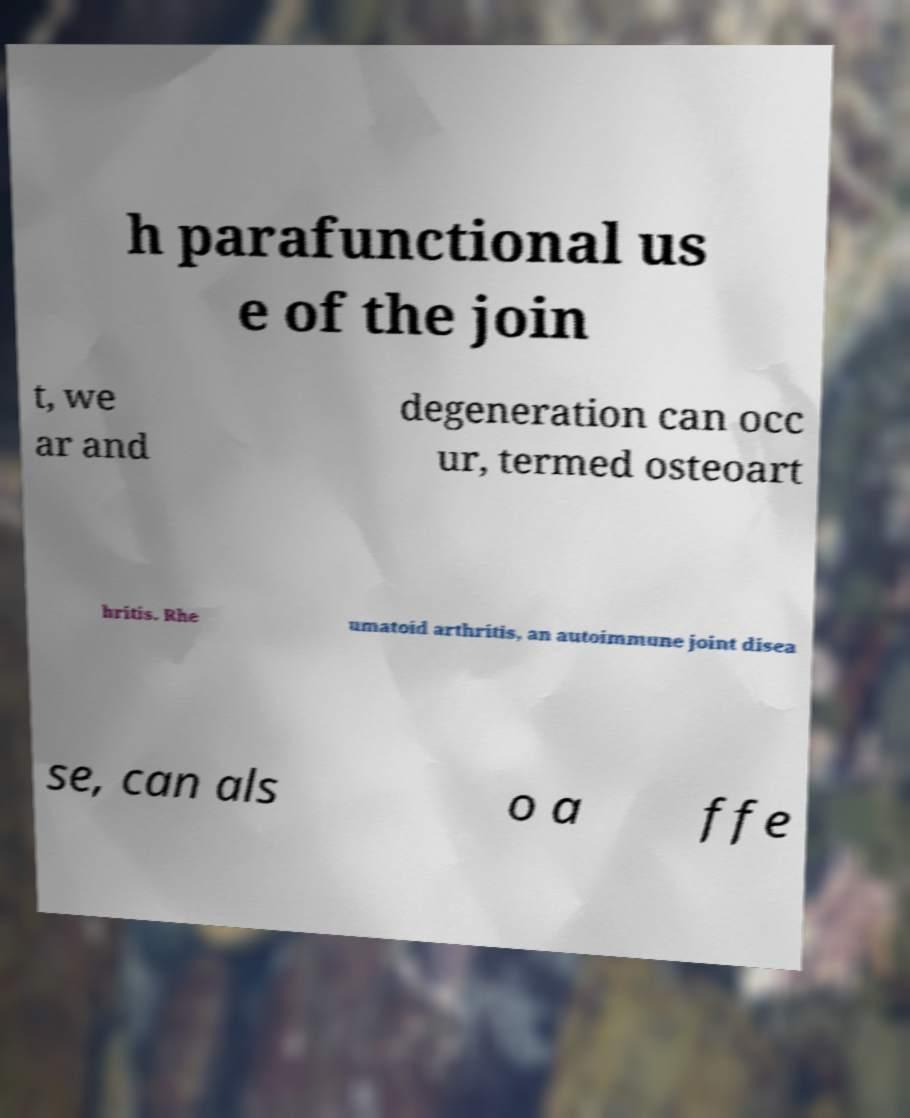Could you extract and type out the text from this image? h parafunctional us e of the join t, we ar and degeneration can occ ur, termed osteoart hritis. Rhe umatoid arthritis, an autoimmune joint disea se, can als o a ffe 